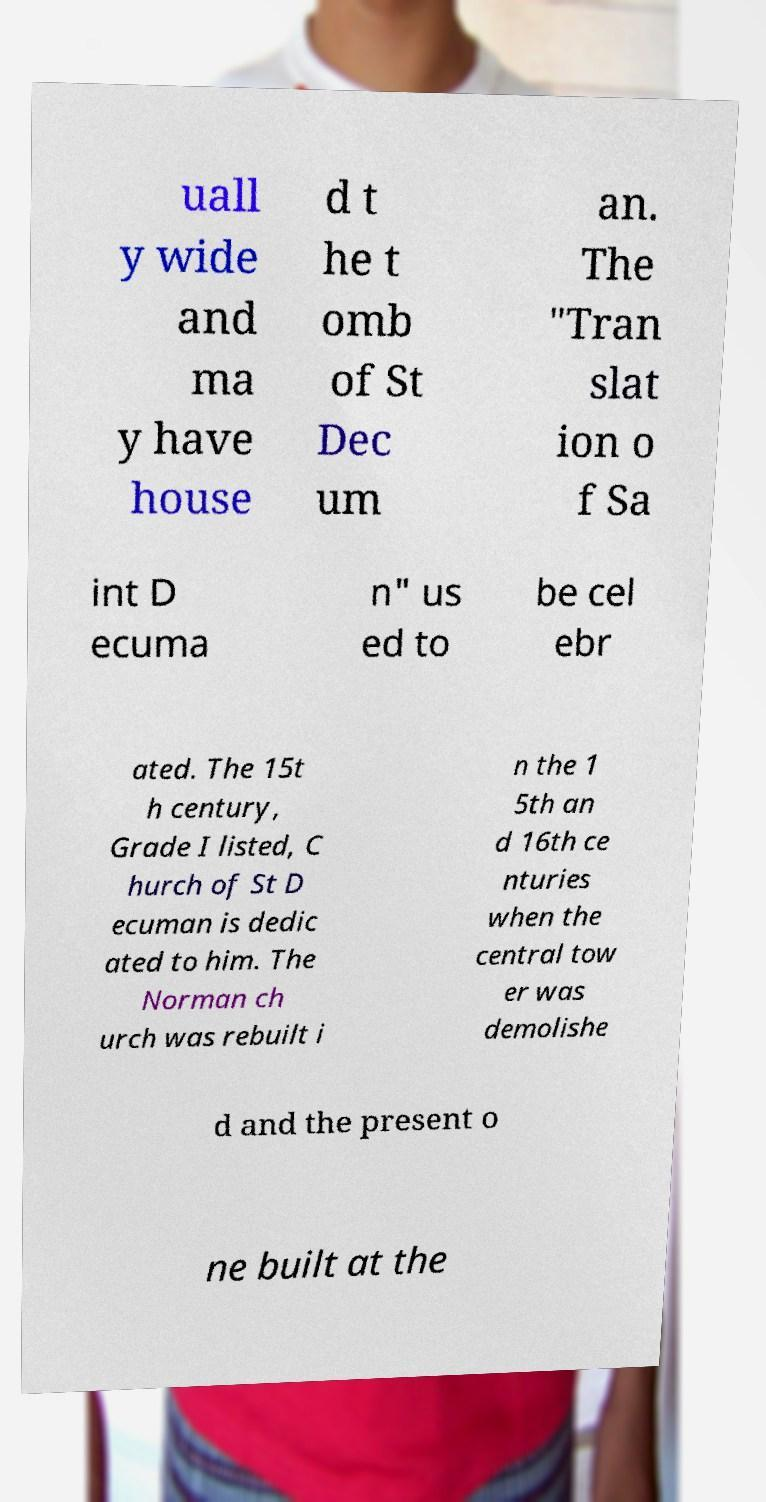There's text embedded in this image that I need extracted. Can you transcribe it verbatim? uall y wide and ma y have house d t he t omb of St Dec um an. The "Tran slat ion o f Sa int D ecuma n" us ed to be cel ebr ated. The 15t h century, Grade I listed, C hurch of St D ecuman is dedic ated to him. The Norman ch urch was rebuilt i n the 1 5th an d 16th ce nturies when the central tow er was demolishe d and the present o ne built at the 